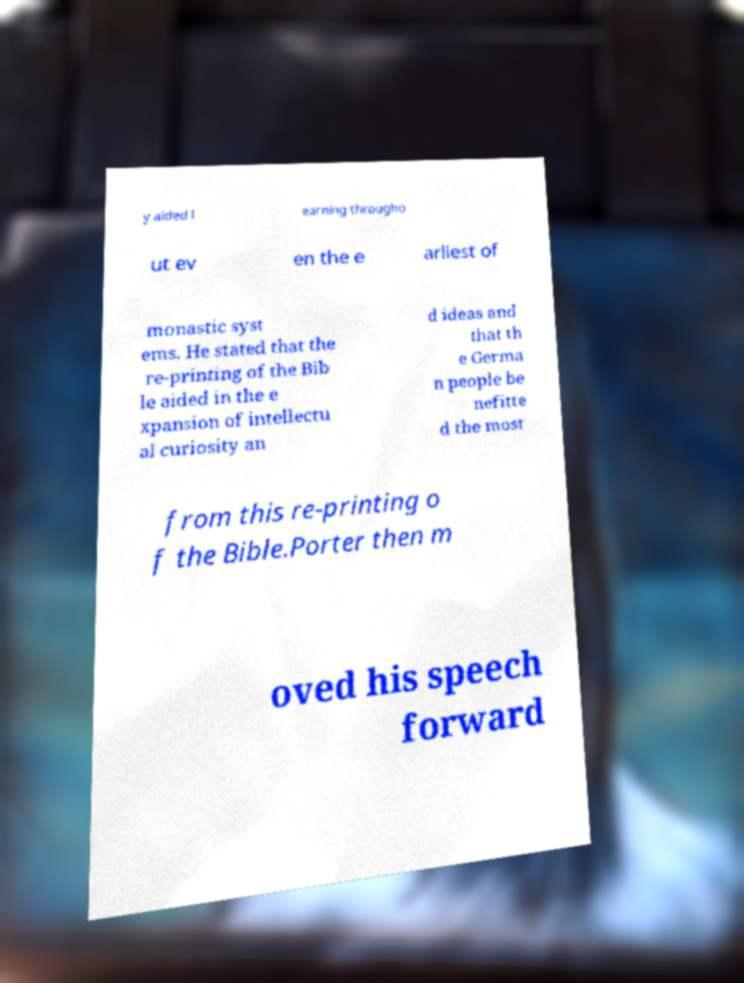Can you accurately transcribe the text from the provided image for me? y aided l earning througho ut ev en the e arliest of monastic syst ems. He stated that the re-printing of the Bib le aided in the e xpansion of intellectu al curiosity an d ideas and that th e Germa n people be nefitte d the most from this re-printing o f the Bible.Porter then m oved his speech forward 